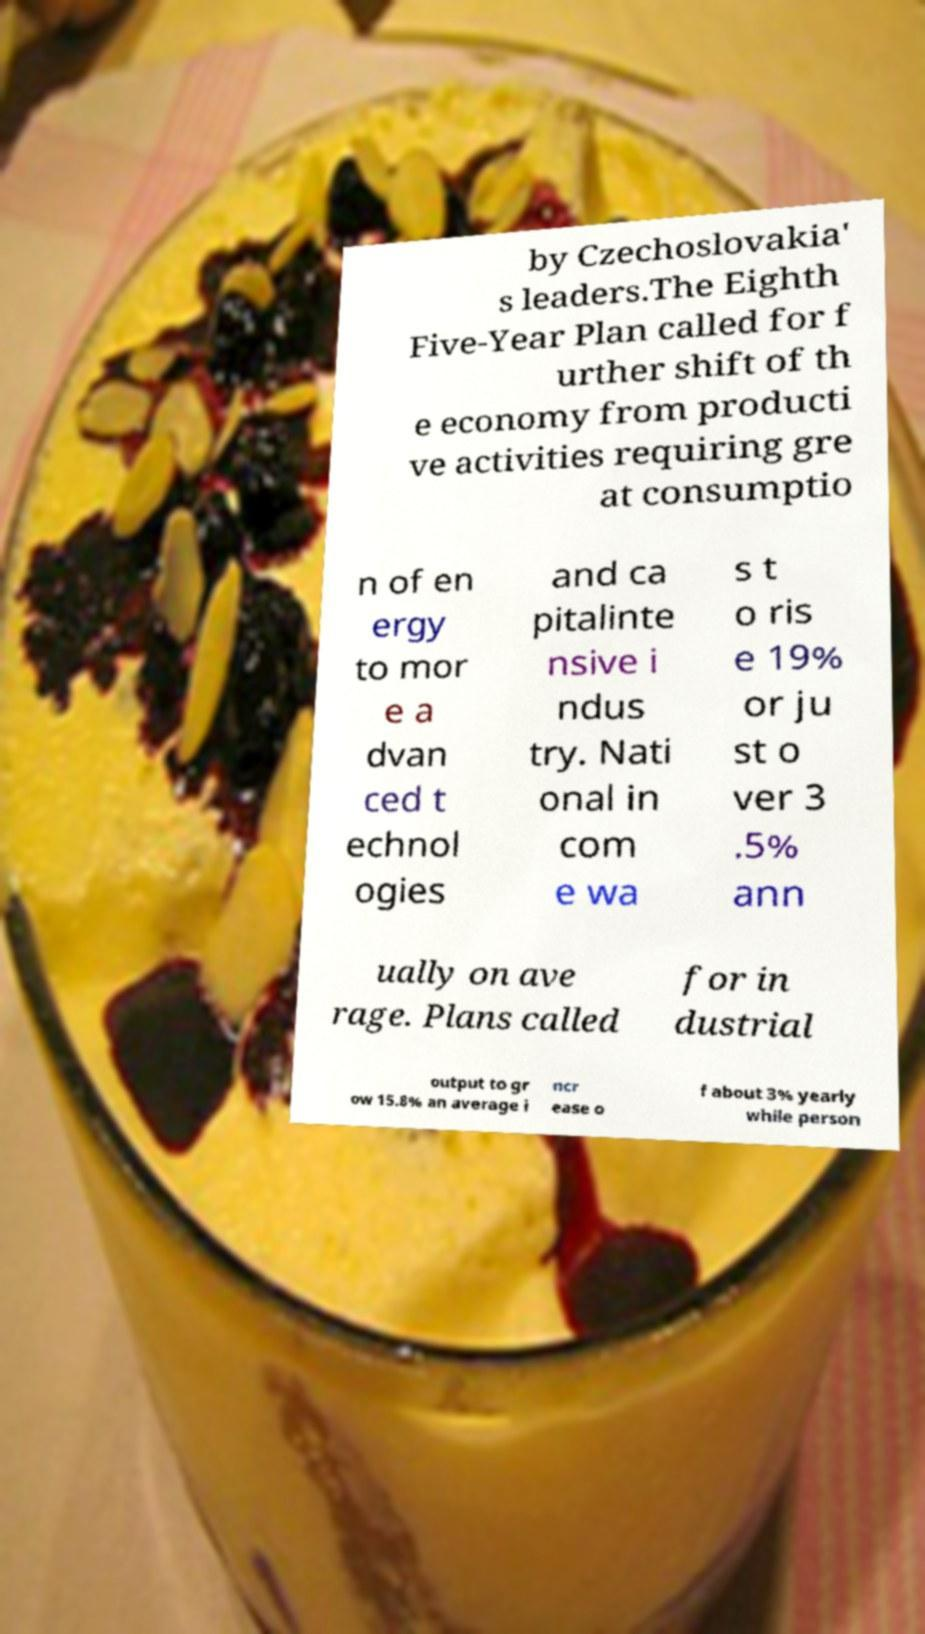What messages or text are displayed in this image? I need them in a readable, typed format. by Czechoslovakia' s leaders.The Eighth Five-Year Plan called for f urther shift of th e economy from producti ve activities requiring gre at consumptio n of en ergy to mor e a dvan ced t echnol ogies and ca pitalinte nsive i ndus try. Nati onal in com e wa s t o ris e 19% or ju st o ver 3 .5% ann ually on ave rage. Plans called for in dustrial output to gr ow 15.8% an average i ncr ease o f about 3% yearly while person 